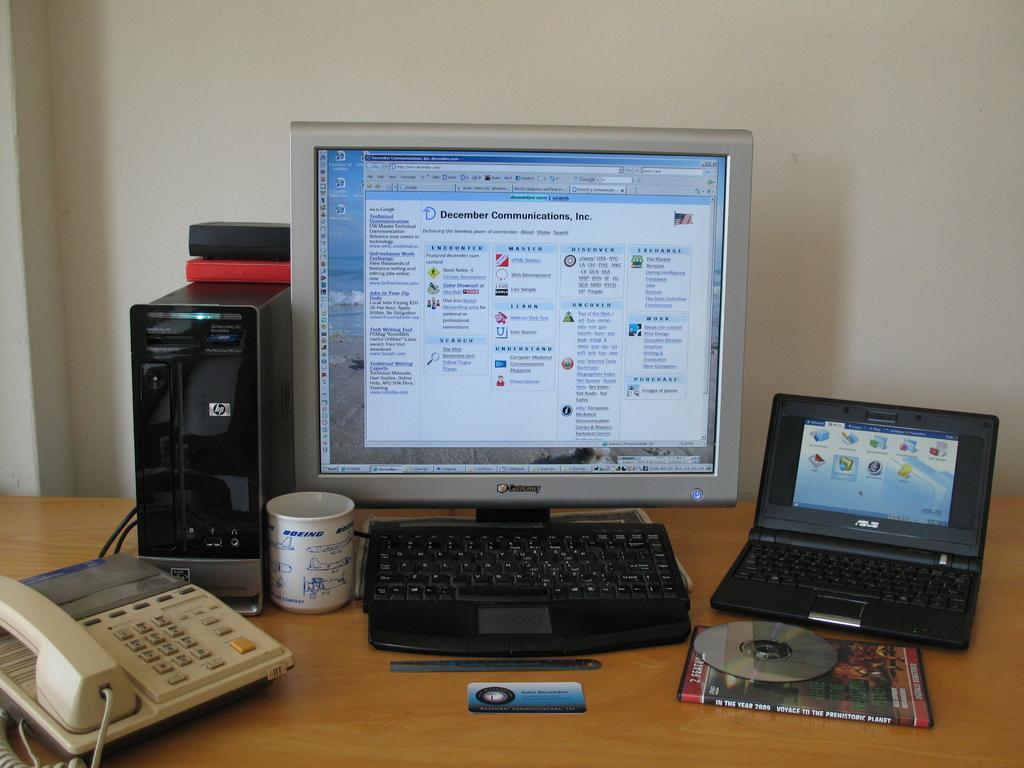Please provide a concise description of this image. In this picture there is a computer , keyboard , laptop, CD, book, telephone, cup ,card and an object on the table. 